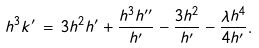<formula> <loc_0><loc_0><loc_500><loc_500>h ^ { 3 } k ^ { \prime } \, = \, 3 h ^ { 2 } h ^ { \prime } + \frac { h ^ { 3 } h ^ { \prime \prime } } { h ^ { \prime } } - \frac { 3 h ^ { 2 } } { h ^ { \prime } } - \frac { \lambda h ^ { 4 } } { 4 h ^ { \prime } } .</formula> 